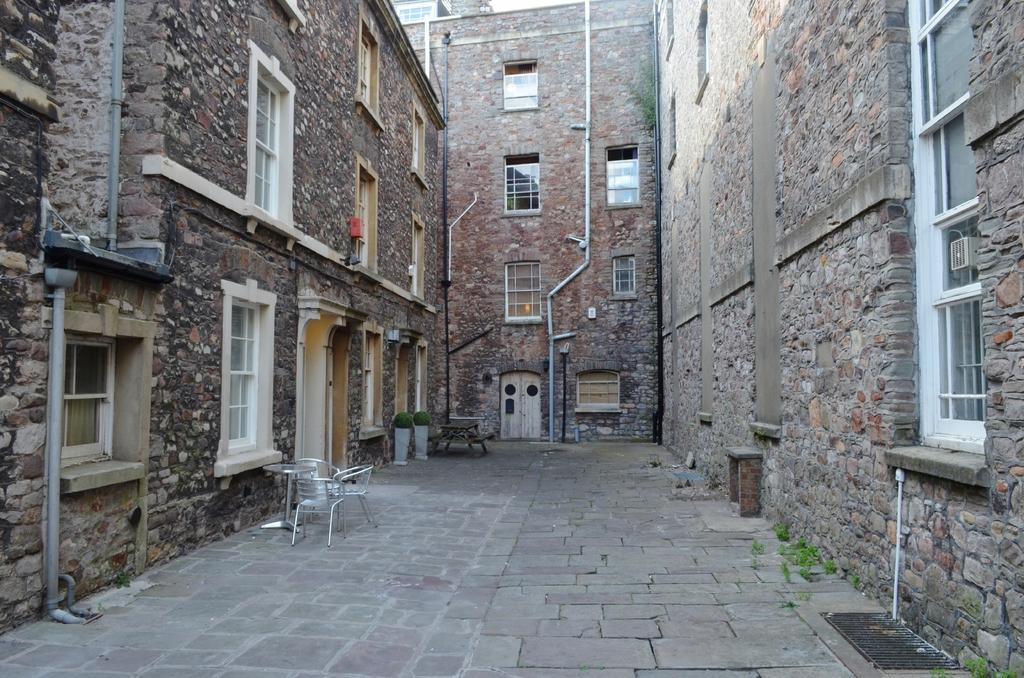What type of material is used to construct the buildings in the image? The buildings in the image are made up of stones. What furniture can be seen on the left side of the image? There are chairs and a table on the left side of the image. What feature allows light to enter the buildings? There are window glasses in the walls of the buildings. What time does the clock on the wall of the building show in the image? There is no clock present in the image, so it is not possible to determine the time. 